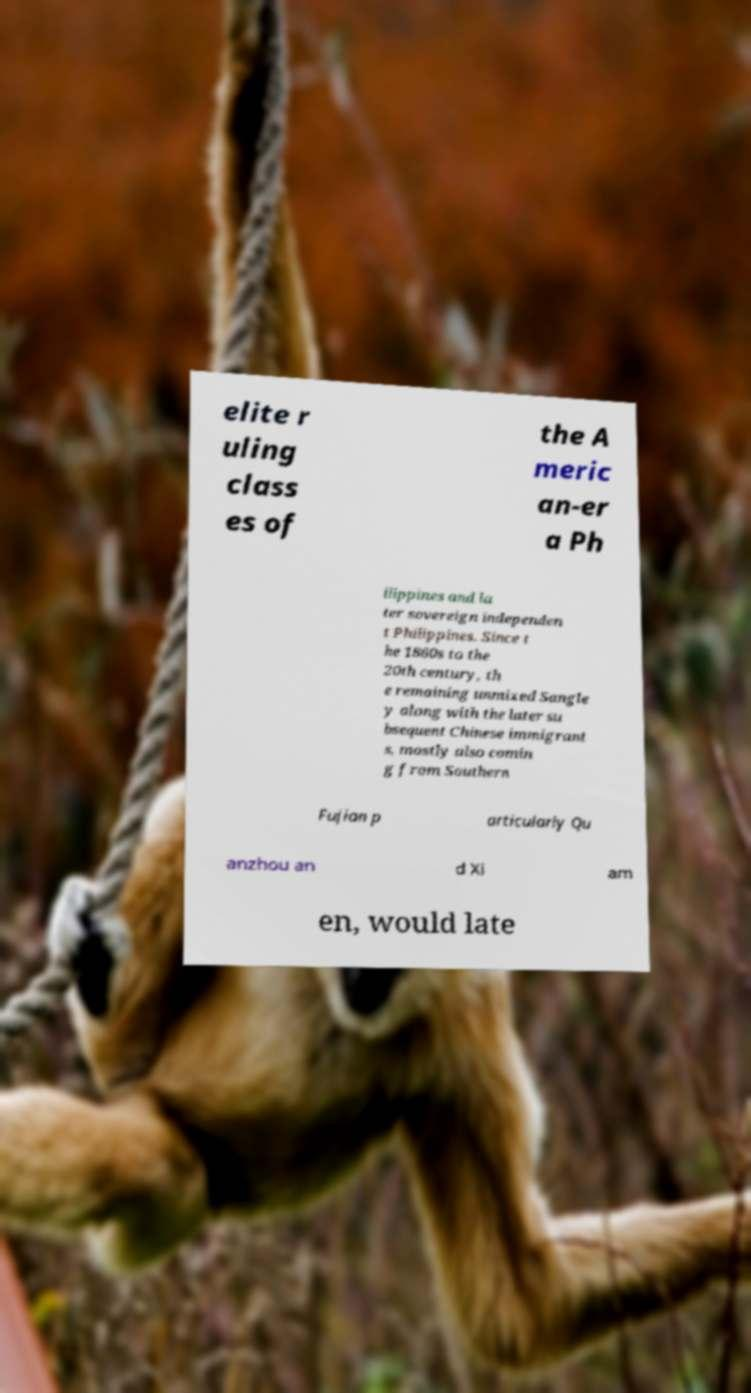I need the written content from this picture converted into text. Can you do that? elite r uling class es of the A meric an-er a Ph ilippines and la ter sovereign independen t Philippines. Since t he 1860s to the 20th century, th e remaining unmixed Sangle y along with the later su bsequent Chinese immigrant s, mostly also comin g from Southern Fujian p articularly Qu anzhou an d Xi am en, would late 